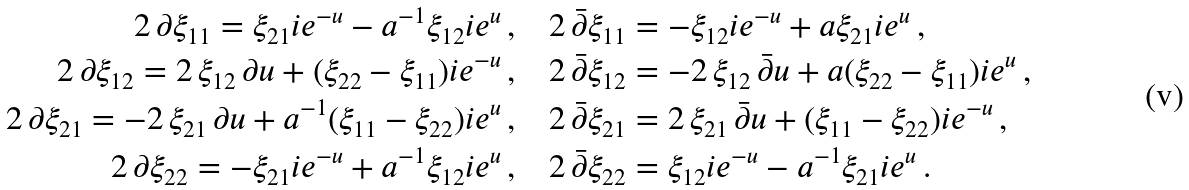<formula> <loc_0><loc_0><loc_500><loc_500>2 \, \partial \xi _ { 1 1 } = \xi _ { 2 1 } i e ^ { - u } - a ^ { - 1 } \xi _ { 1 2 } i e ^ { u } \, , \quad & 2 \, \bar { \partial } \xi _ { 1 1 } = - \xi _ { 1 2 } i e ^ { - u } + a \xi _ { 2 1 } i e ^ { u } \, , \\ 2 \, \partial \xi _ { 1 2 } = 2 \, \xi _ { 1 2 } \, \partial u + ( \xi _ { 2 2 } - \xi _ { 1 1 } ) i e ^ { - u } \, , \quad & 2 \, \bar { \partial } \xi _ { 1 2 } = - 2 \, \xi _ { 1 2 } \, \bar { \partial } u + a ( \xi _ { 2 2 } - \xi _ { 1 1 } ) i e ^ { u } \, , \\ 2 \, \partial \xi _ { 2 1 } = - 2 \, \xi _ { 2 1 } \, \partial u + a ^ { - 1 } ( \xi _ { 1 1 } - \xi _ { 2 2 } ) i e ^ { u } \, , \quad & 2 \, \bar { \partial } \xi _ { 2 1 } = 2 \, \xi _ { 2 1 } \, \bar { \partial } u + ( \xi _ { 1 1 } - \xi _ { 2 2 } ) i e ^ { - u } \, , \\ 2 \, \partial \xi _ { 2 2 } = - \xi _ { 2 1 } i e ^ { - u } + a ^ { - 1 } \xi _ { 1 2 } i e ^ { u } \, , \quad & 2 \, \bar { \partial } \xi _ { 2 2 } = \xi _ { 1 2 } i e ^ { - u } - a ^ { - 1 } \xi _ { 2 1 } i e ^ { u } \, .</formula> 